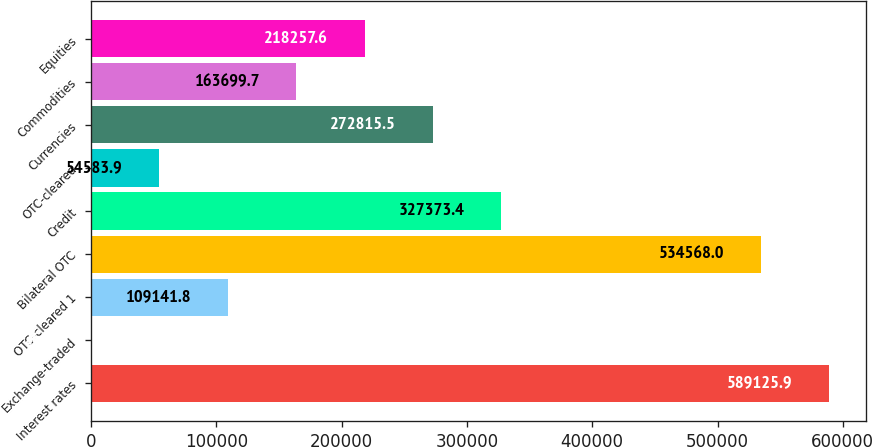<chart> <loc_0><loc_0><loc_500><loc_500><bar_chart><fcel>Interest rates<fcel>Exchange-traded<fcel>OTC-cleared 1<fcel>Bilateral OTC<fcel>Credit<fcel>OTC-cleared<fcel>Currencies<fcel>Commodities<fcel>Equities<nl><fcel>589126<fcel>26<fcel>109142<fcel>534568<fcel>327373<fcel>54583.9<fcel>272816<fcel>163700<fcel>218258<nl></chart> 